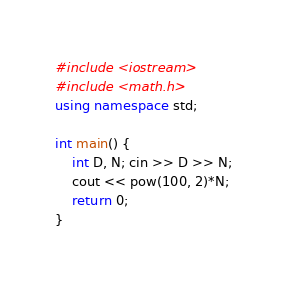<code> <loc_0><loc_0><loc_500><loc_500><_C++_>#include <iostream>
#include <math.h>
using namespace std;
 
int main() {
	int D, N; cin >> D >> N;
    cout << pow(100, 2)*N;
	return 0;
}</code> 